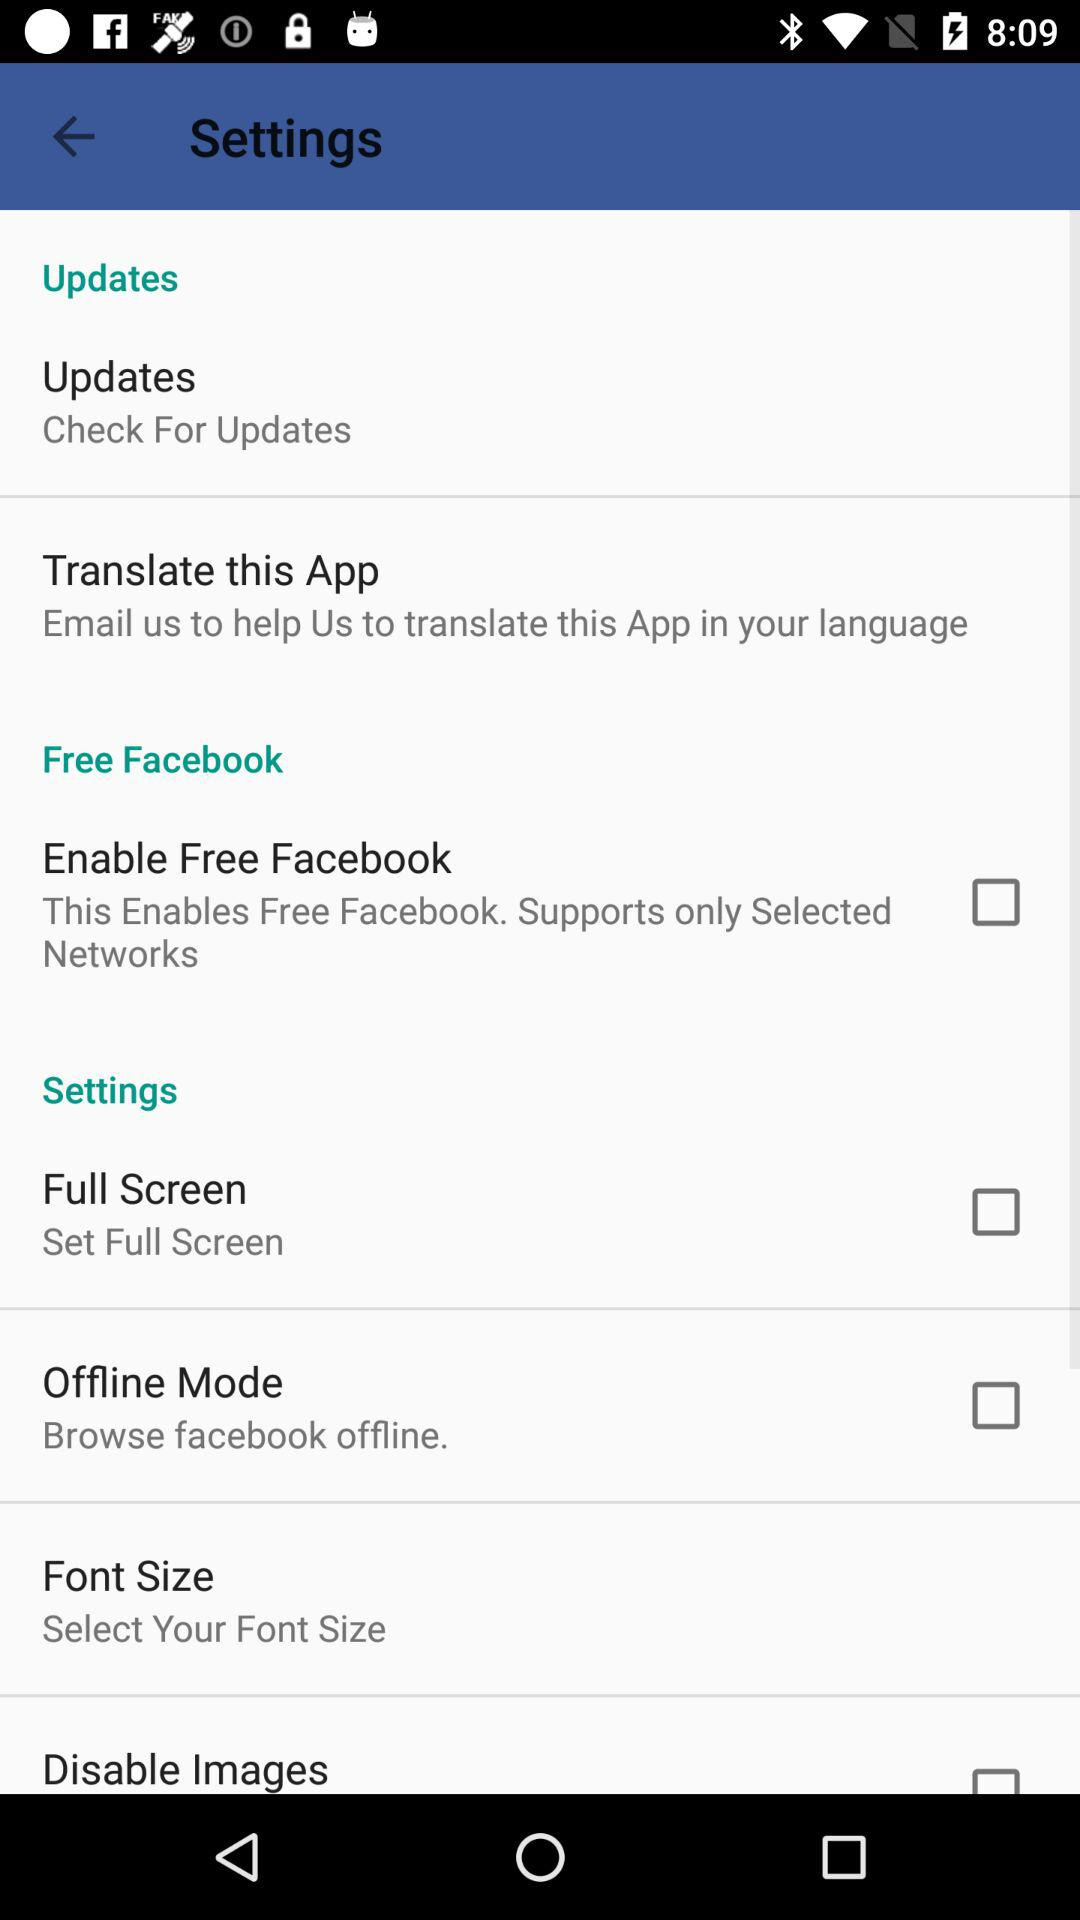Are any updates available?
When the provided information is insufficient, respond with <no answer>. <no answer> 